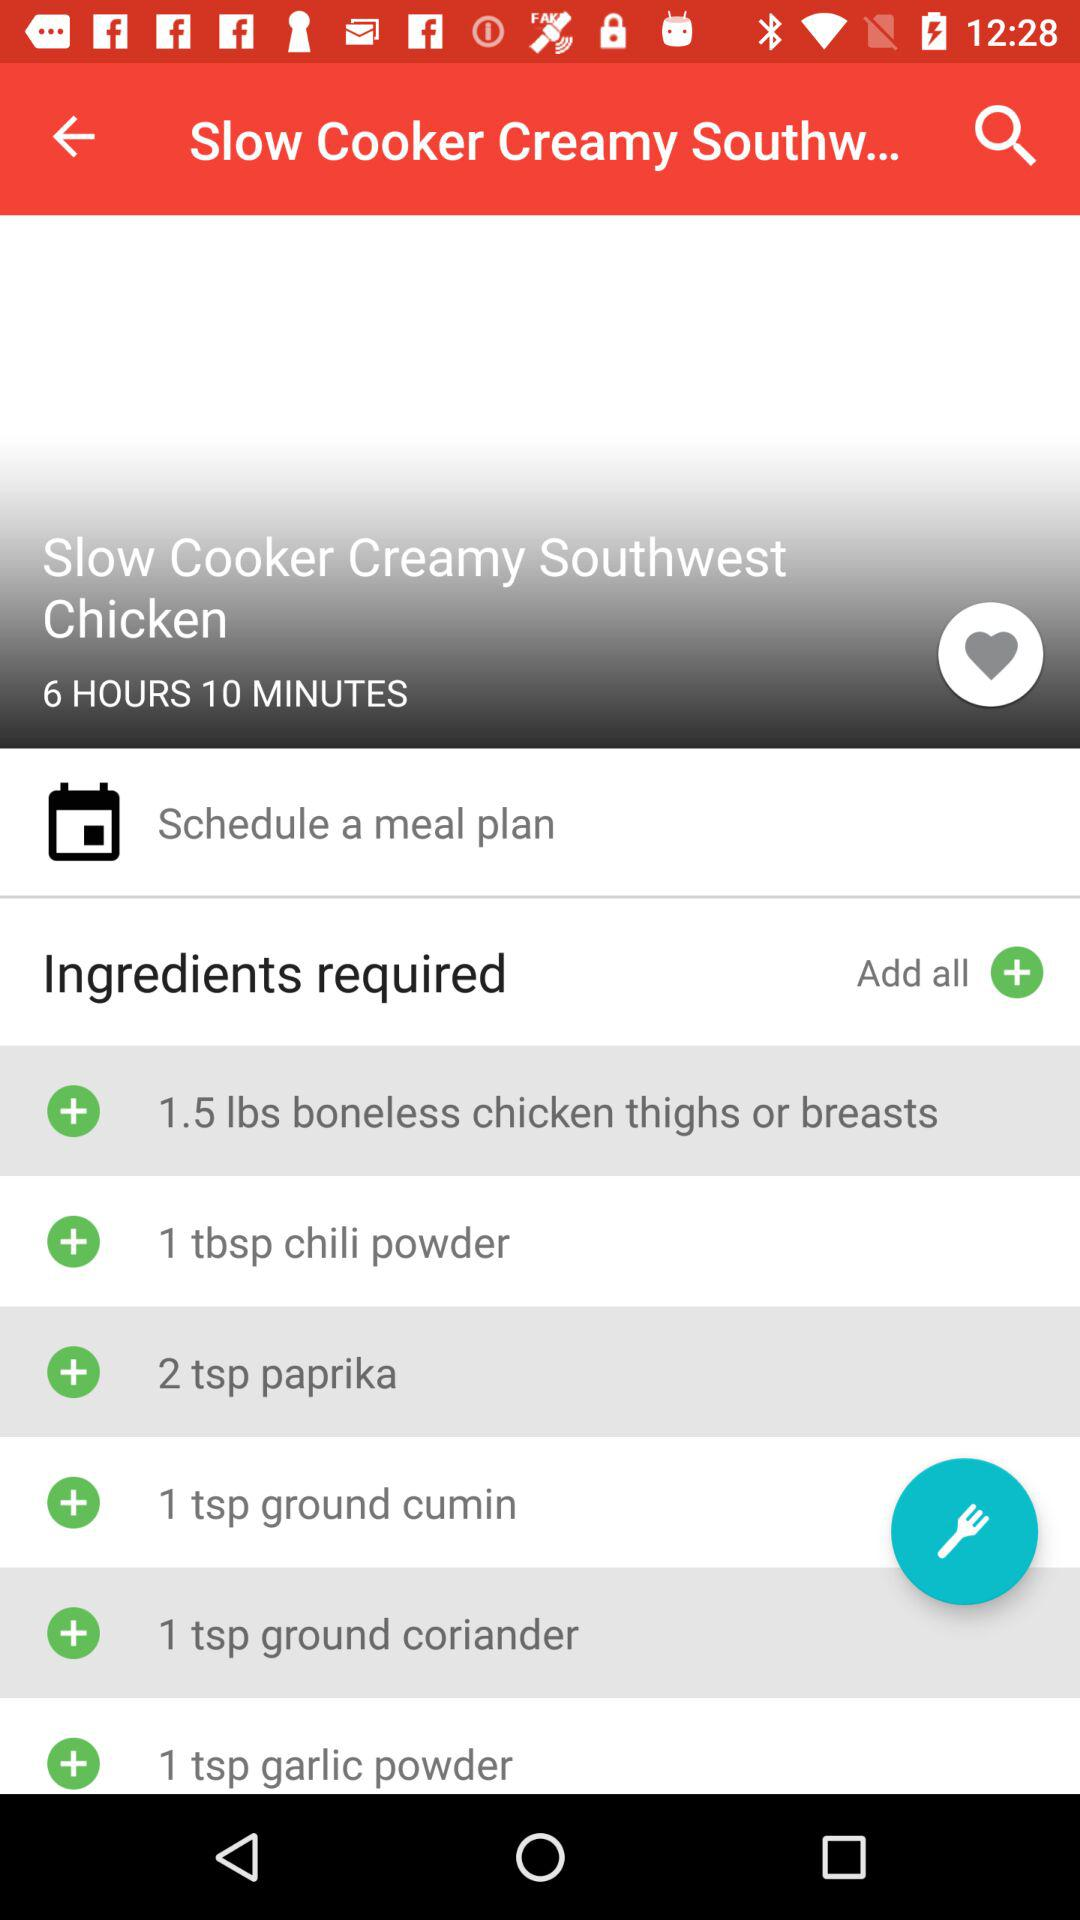How many boneless chicken thighs or breasts are required? There are 1.5 pounds of boneless chicken thighs or breasts required. 